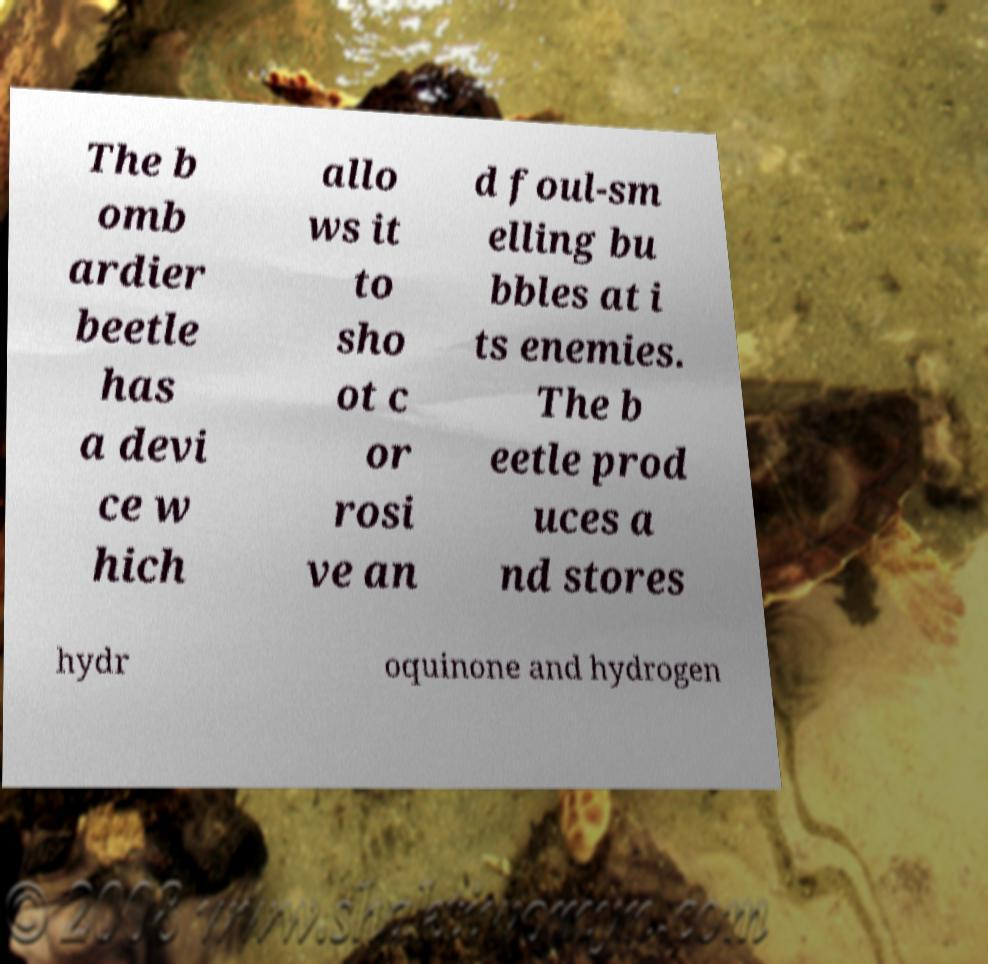What messages or text are displayed in this image? I need them in a readable, typed format. The b omb ardier beetle has a devi ce w hich allo ws it to sho ot c or rosi ve an d foul-sm elling bu bbles at i ts enemies. The b eetle prod uces a nd stores hydr oquinone and hydrogen 